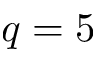<formula> <loc_0><loc_0><loc_500><loc_500>q = 5</formula> 